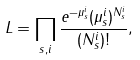Convert formula to latex. <formula><loc_0><loc_0><loc_500><loc_500>L = \prod _ { s , i } \frac { e ^ { - \mu _ { s } ^ { i } } ( \mu _ { s } ^ { i } ) ^ { N _ { s } ^ { i } } } { ( N _ { s } ^ { i } ) ! } ,</formula> 